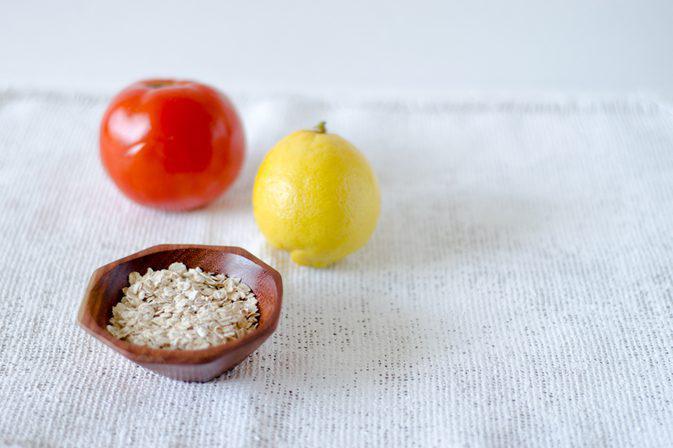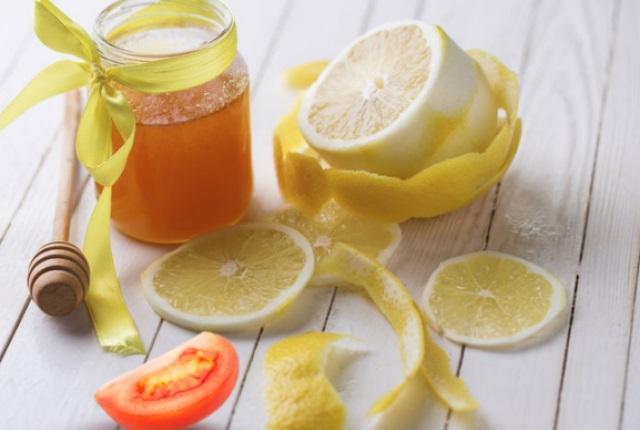The first image is the image on the left, the second image is the image on the right. Examine the images to the left and right. Is the description "One image includes a non-jar type glass containing reddish-orange liquid, along with a whole tomato and a whole lemon." accurate? Answer yes or no. No. The first image is the image on the left, the second image is the image on the right. Examine the images to the left and right. Is the description "One of the images features a glass of tomato juice." accurate? Answer yes or no. No. 